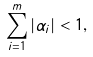<formula> <loc_0><loc_0><loc_500><loc_500>\sum _ { i = 1 } ^ { m } | \alpha _ { i } | < 1 ,</formula> 